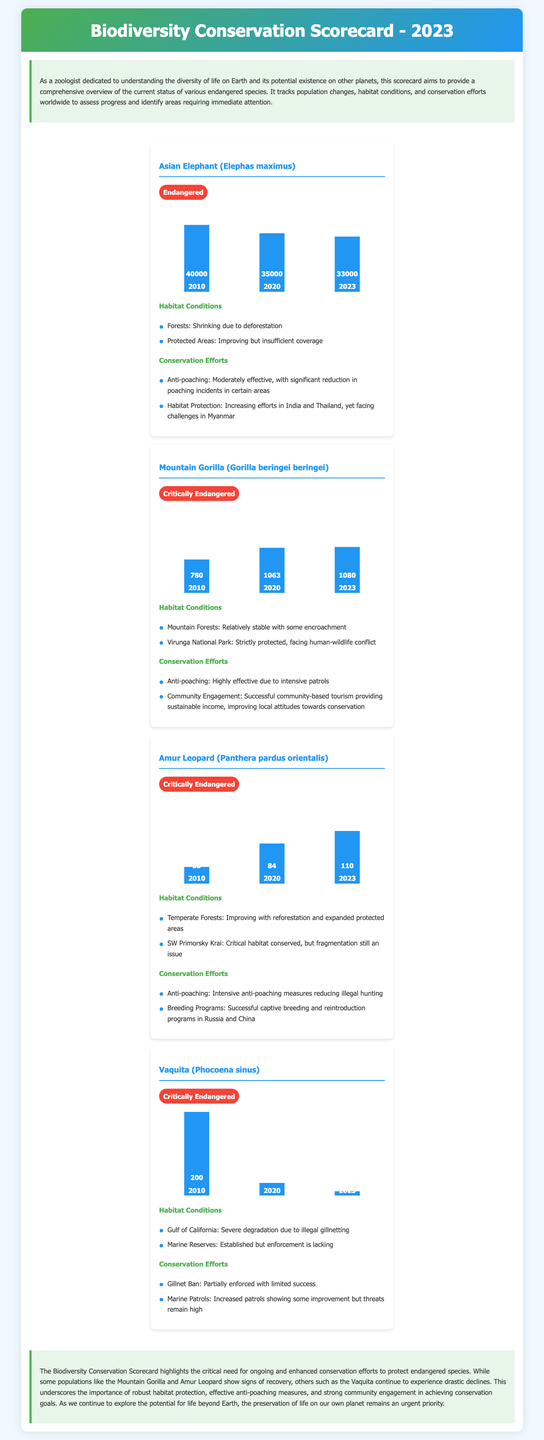What is the status of the Asian Elephant? The status of the Asian Elephant is indicated in the document as a conservation category, which is classified as "Endangered."
Answer: Endangered What was the population of the Mountain Gorilla in 2023? The population of the Mountain Gorilla in 2023 can be found in the population chart, which shows 1080 individuals.
Answer: 1080 What were the habitat conditions for the Amur Leopard? The habitat conditions for the Amur Leopard are described in the document, highlighting improvements and issues such as "Improving with reforestation and expanded protected areas."
Answer: Improving with reforestation and expanded protected areas How many Vaquitas were reported in 2020? The Vaquita's population in 2020 is shown in the population chart, listing 30 individuals.
Answer: 30 What conservation effort is noted as highly effective for the Mountain Gorilla? The conservation effort noted for the Mountain Gorilla is "Anti-poaching," which is stated as being highly effective due to intensive patrols.
Answer: Anti-poaching Which species experienced the most significant population decline from 2010 to 2023? The species that experienced the most significant decline is assessed through the population data, showcasing drastic reductions, specifically the Vaquita, which declined from 200 in 2010 to 10 in 2023.
Answer: Vaquita What is the primary threat to the Vaquita's habitat? The primary threat to the Vaquita is detailed in the habitat conditions section, indicating "Severe degradation due to illegal gillnetting."
Answer: Severe degradation due to illegal gillnetting What conservation strategy is employed for the Amur Leopard? A conservation strategy mentioned for the Amur Leopard includes "Intensive anti-poaching measures," which are aimed at reducing illegal hunting.
Answer: Intensive anti-poaching measures How did the population of the Asian Elephant change from 2010 to 2023? The population change for the Asian Elephant is evidenced by comparing years, indicating a decline from 40,000 in 2010 to 33,000 in 2023.
Answer: Decline from 40,000 to 33,000 